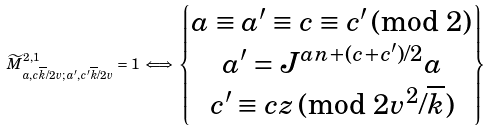<formula> <loc_0><loc_0><loc_500><loc_500>\widetilde { M } ^ { 2 , 1 } _ { a , c \overline { k } / 2 v ; \, a ^ { \prime } , c ^ { \prime } \overline { k } / 2 v } = 1 \iff \left \{ \begin{matrix} a \equiv a ^ { \prime } \equiv c \equiv c ^ { \prime } \, \text {(mod } 2 ) \\ a ^ { \prime } = J ^ { a n + ( c + c ^ { \prime } ) / 2 } a \\ c ^ { \prime } \equiv c z \, \text {(mod } 2 v ^ { 2 } / \overline { k } ) \end{matrix} \right \}</formula> 